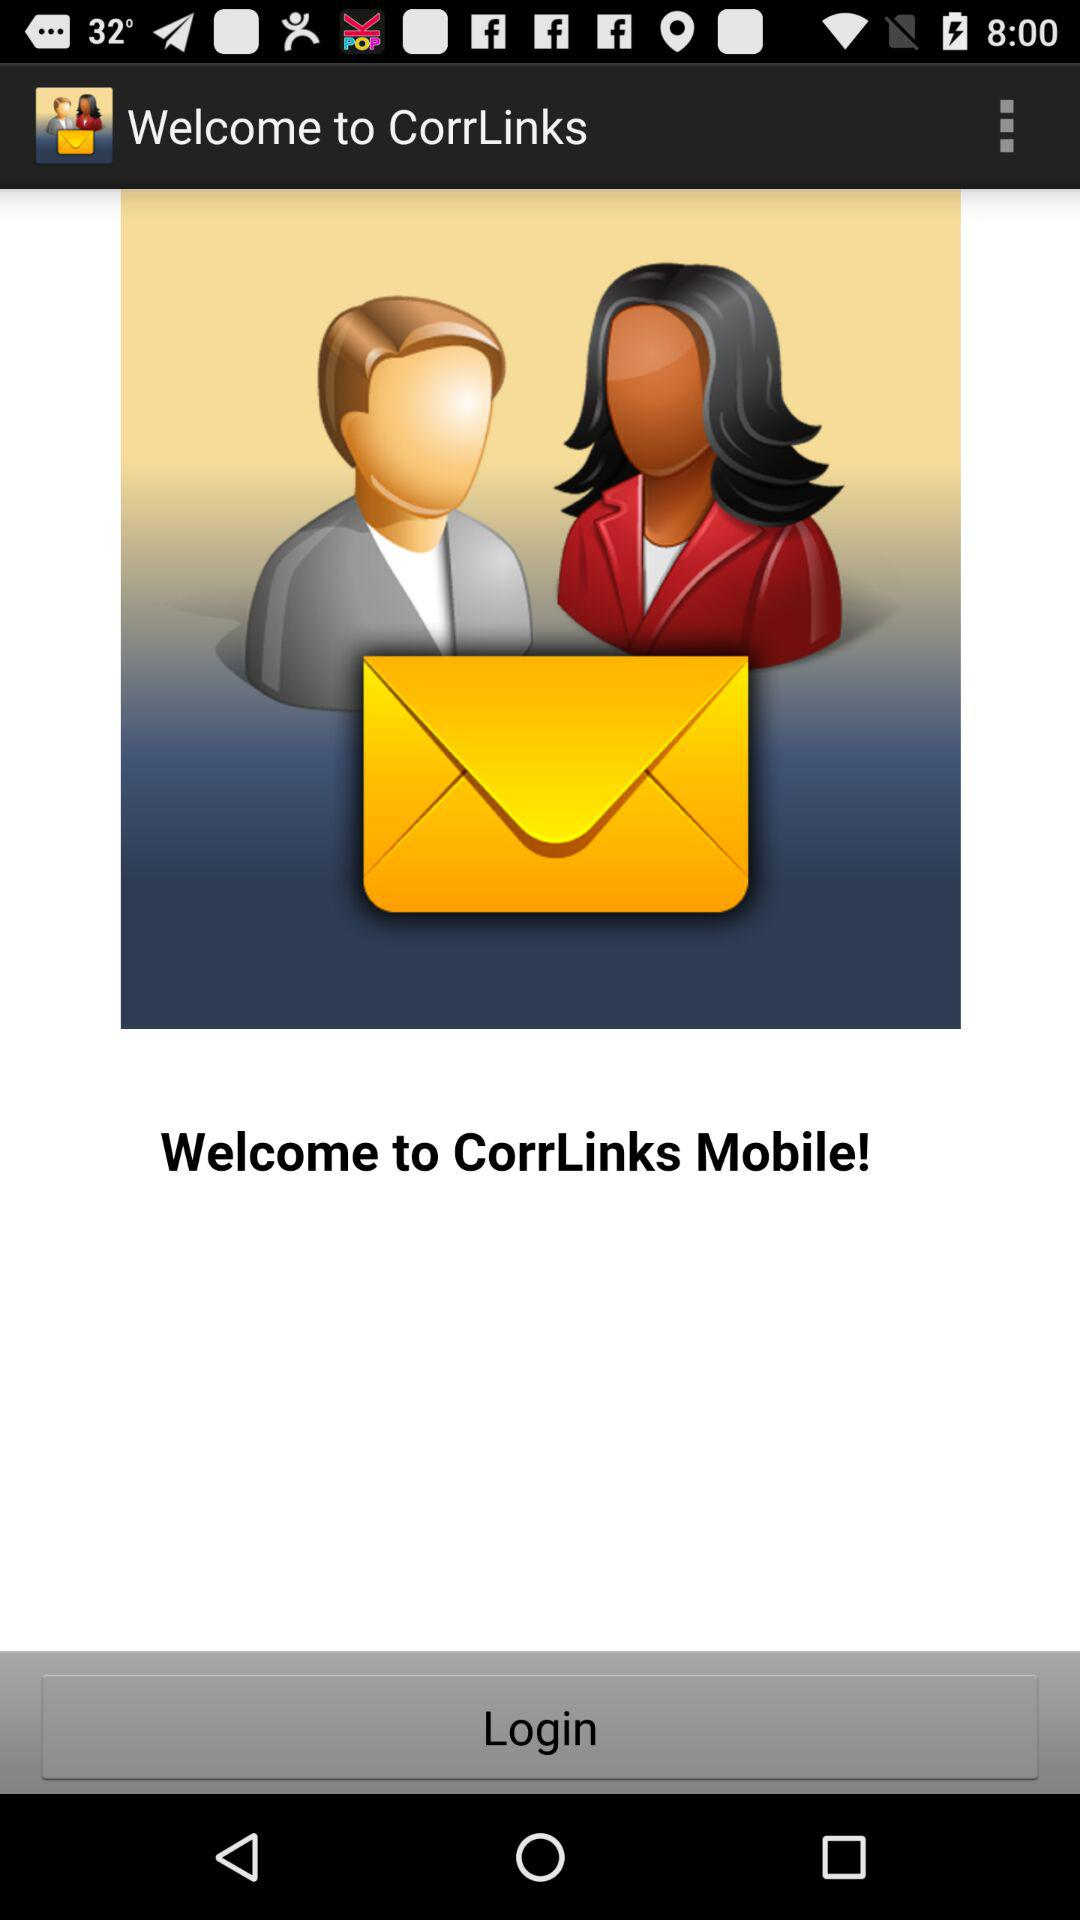What is the name of the application? The name of the application is "CorrLinks". 